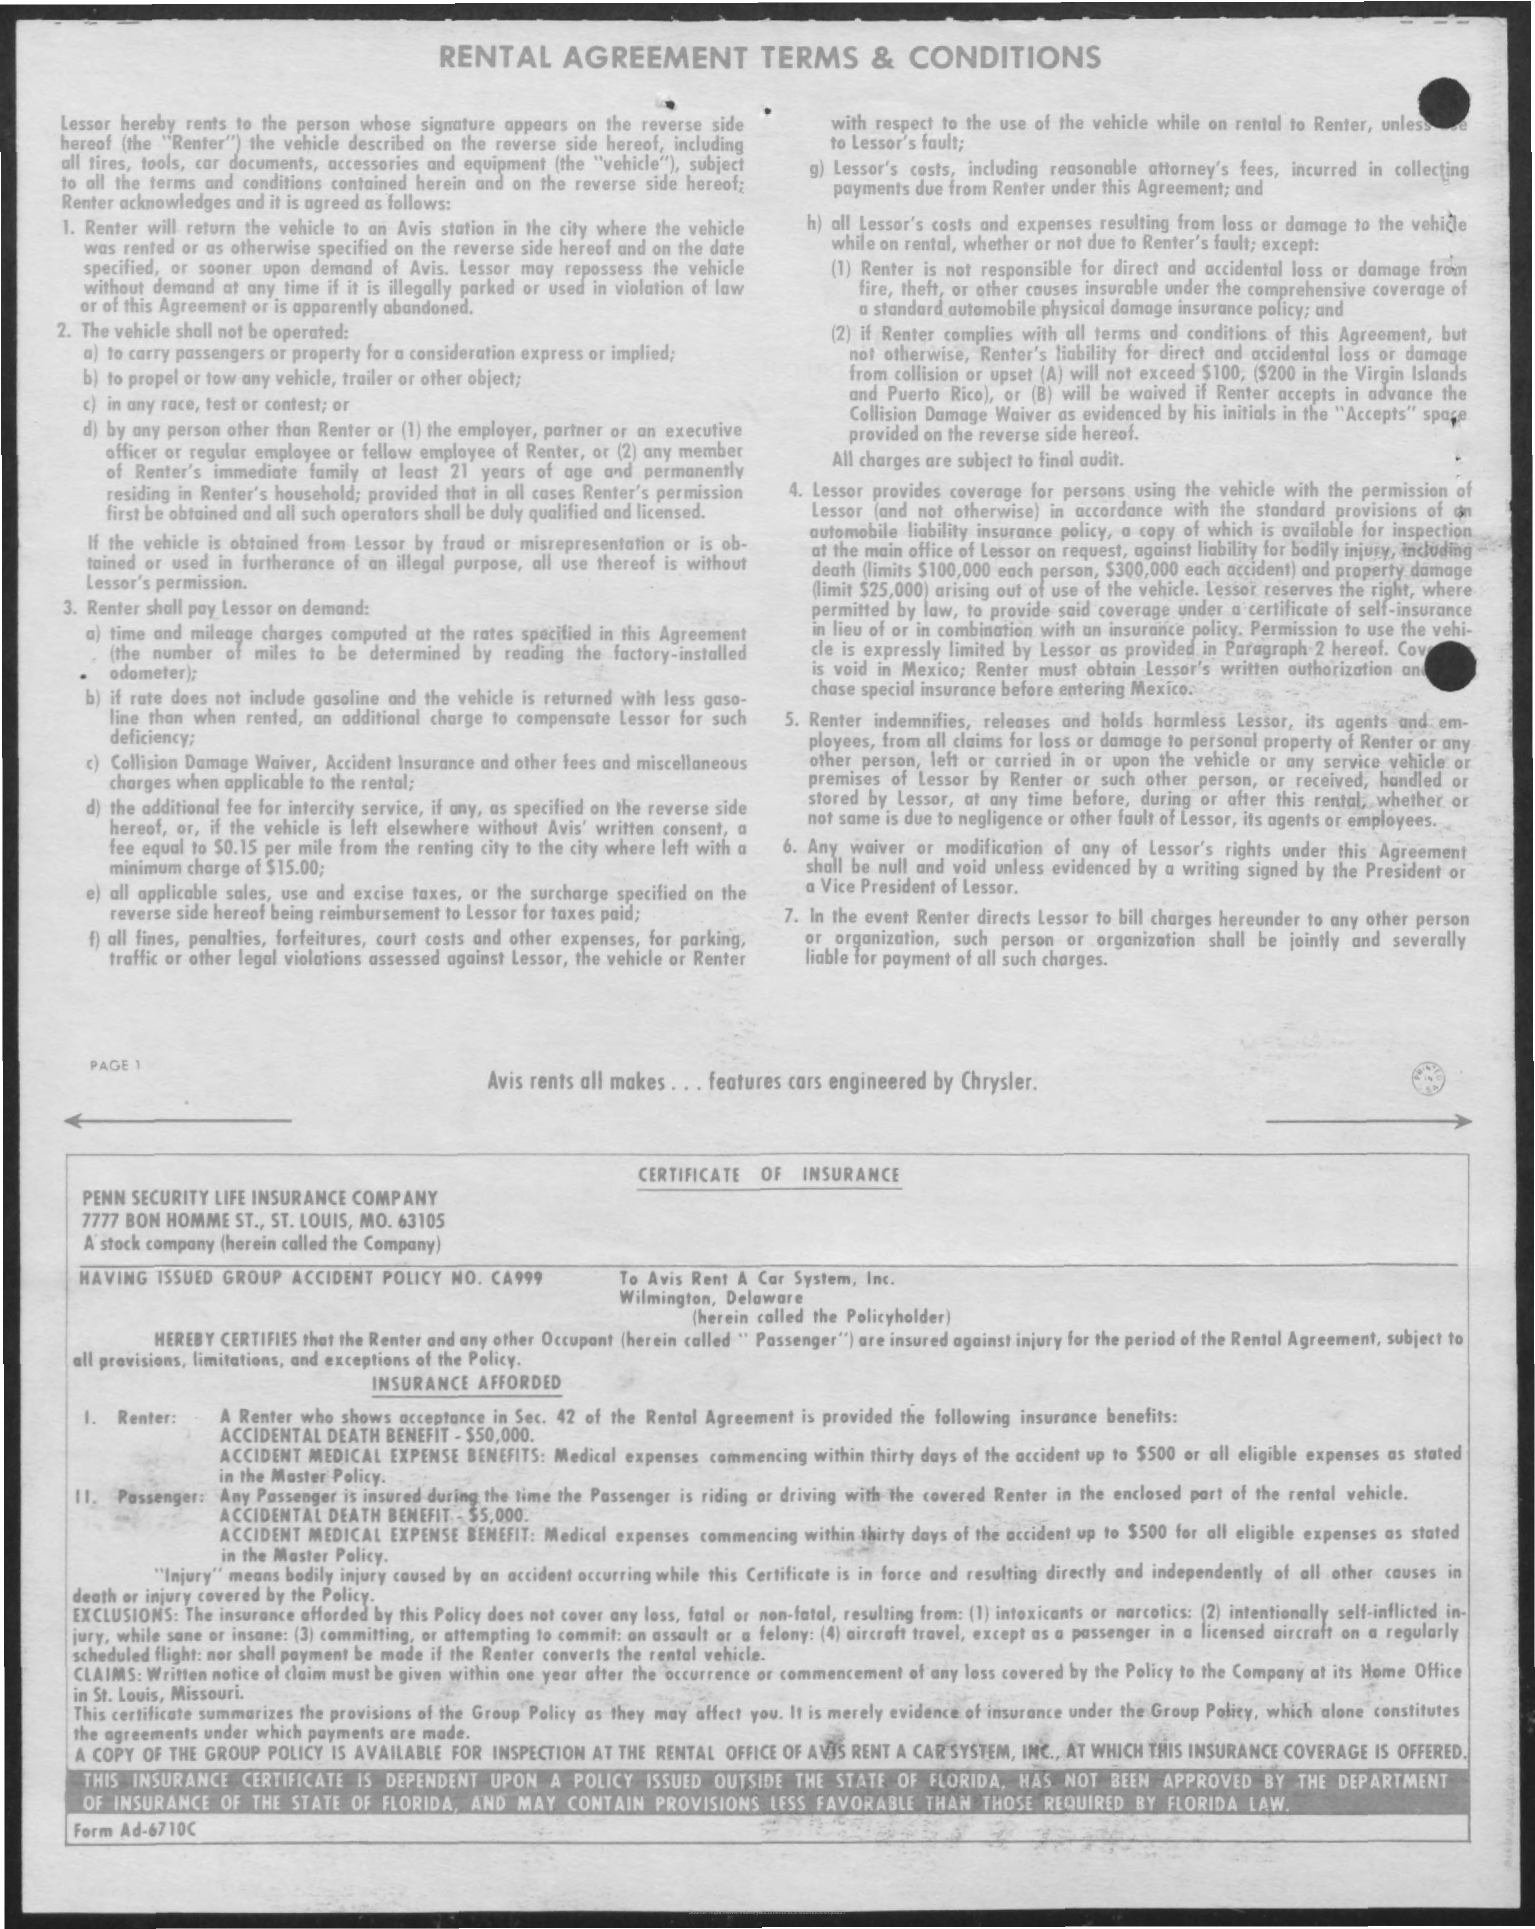Identify some key points in this picture. The title of the document is 'Rental Agreement Terms & Conditions.' 